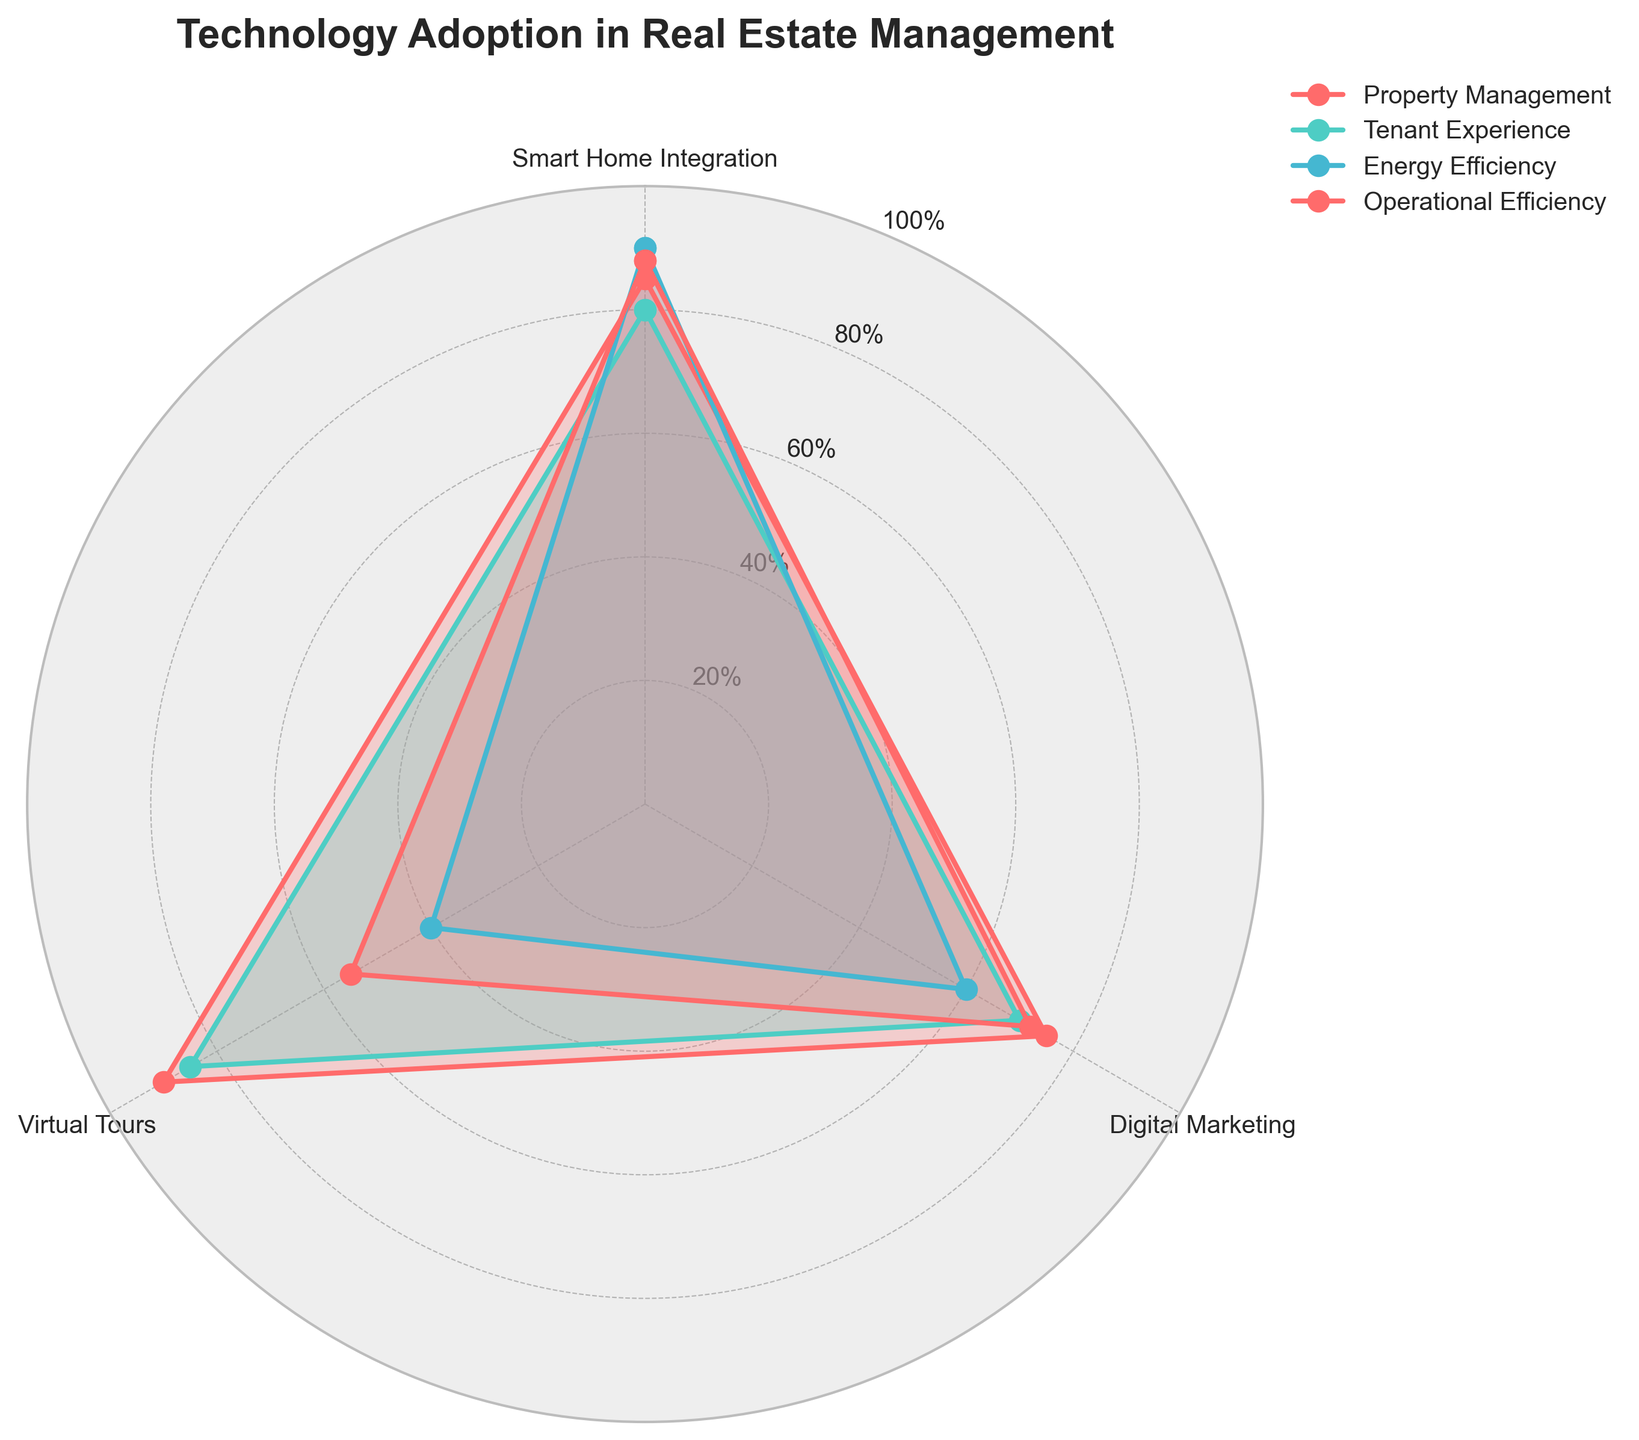What is the highest value recorded for Smart Home Integration? The figure shows values plotted around the radar chart for each category. The highest value can be identified by finding the largest data point within the Smart Home Integration axis.
Answer: 90 Which category shows the lowest value for Virtual Tours? Look at the Virtual Tours axis and identify which category has the smallest value plotted.
Answer: Energy Efficiency In which category do Operational Efficiency and Digital Marketing differ the most? Identify the respective values for Operational Efficiency and Digital Marketing in each category and compare the differences. The largest difference will determine the answer.
Answer: Energy Efficiency Which category has the highest overall average value across all three technological areas? Calculate the average of the three values for each category and compare them to identify the highest average.
Answer: Property Management What is the sum of the values for Tenant Experience in Smart Home Integration and Virtual Tours? Add the values for Tenant Experience in the Smart Home Integration and Virtual Tours axes.
Answer: 165 Between Property Management and Tenant Experience, which category performs better in Digital Marketing? Compare the values of Digital Marketing for Property Management and Tenant Experience directly.
Answer: Property Management What is the difference between the highest and lowest values for Energy Efficiency across all three technological areas? Identify the highest and lowest values for Energy Efficiency across all three axes and subtract the lowest from the highest.
Answer: 50 Which technological area shows the most balanced adoption across all four categories? Determine the stability by comparing how close the values are to each other within each technological area for all categories. The most balanced area will have the smallest range among its values.
Answer: Smart Home Integration 